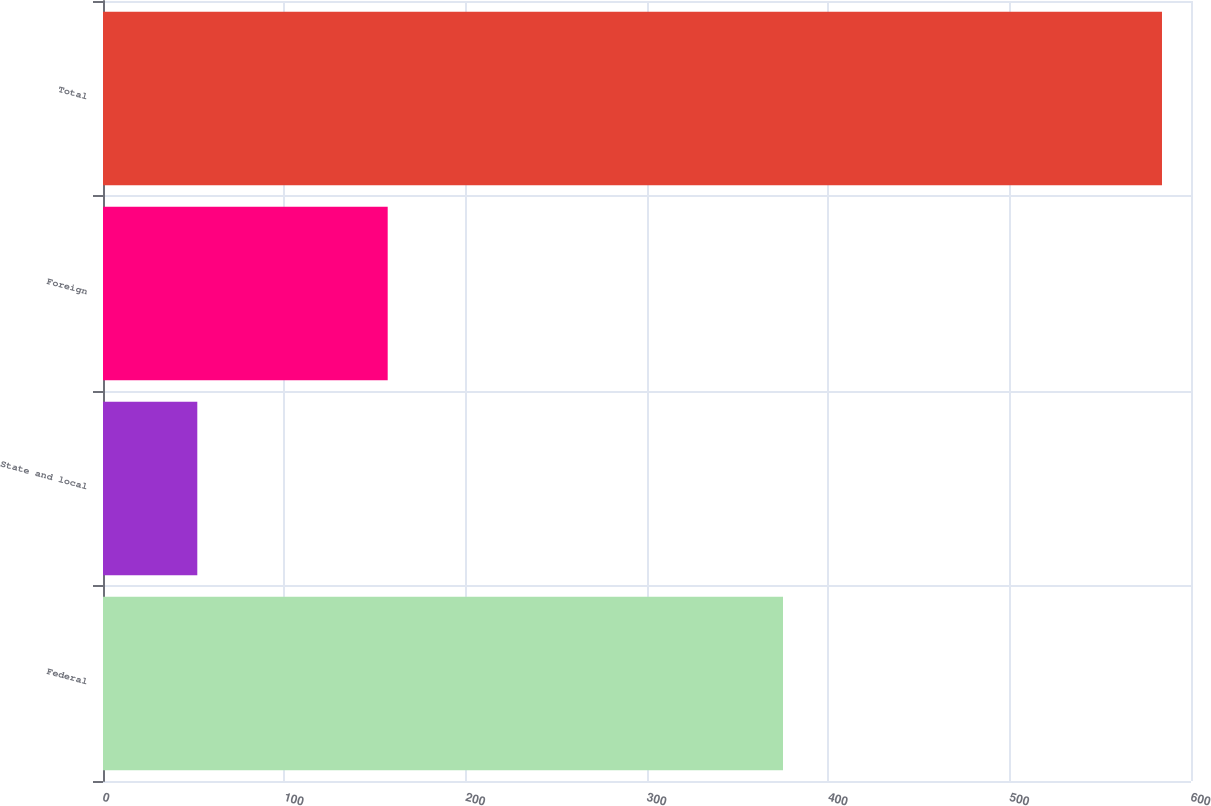Convert chart to OTSL. <chart><loc_0><loc_0><loc_500><loc_500><bar_chart><fcel>Federal<fcel>State and local<fcel>Foreign<fcel>Total<nl><fcel>375<fcel>52<fcel>157<fcel>584<nl></chart> 